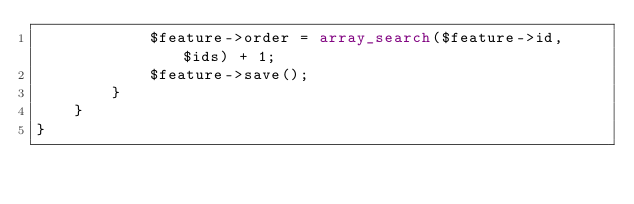Convert code to text. <code><loc_0><loc_0><loc_500><loc_500><_PHP_>            $feature->order = array_search($feature->id, $ids) + 1;
            $feature->save();
        }
    }
}</code> 